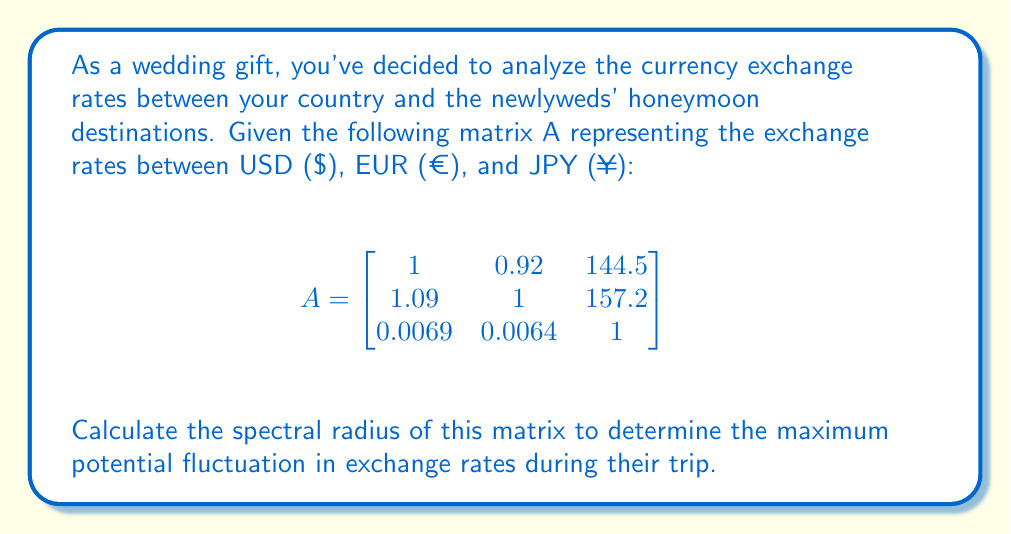Solve this math problem. To find the spectral radius of matrix A, we need to follow these steps:

1) First, calculate the characteristic polynomial of A:
   $$det(A - \lambda I) = \begin{vmatrix}
   1-\lambda & 0.92 & 144.5 \\
   1.09 & 1-\lambda & 157.2 \\
   0.0069 & 0.0064 & 1-\lambda
   \end{vmatrix} = 0$$

2) Expand the determinant:
   $$(1-\lambda)((1-\lambda)(1-\lambda) - 0.0064 \cdot 157.2) - 0.92(1.09(1-\lambda) - 0.0069 \cdot 157.2) + 144.5(1.09 \cdot 0.0064 - 0.0069(1-\lambda)) = 0$$

3) Simplify to get the characteristic equation:
   $$-\lambda^3 + 3\lambda^2 - 3\lambda + 1 = 0$$

4) The roots of this equation are the eigenvalues of A. Using numerical methods or a computer algebra system, we find the roots:
   $$\lambda_1 \approx 2.2470$$
   $$\lambda_2 \approx 0.3765 + 0.5321i$$
   $$\lambda_3 \approx 0.3765 - 0.5321i$$

5) The spectral radius is the maximum absolute value of the eigenvalues:
   $$\rho(A) = \max_{i} |\lambda_i| = |\lambda_1| \approx 2.2470$$
Answer: 2.2470 